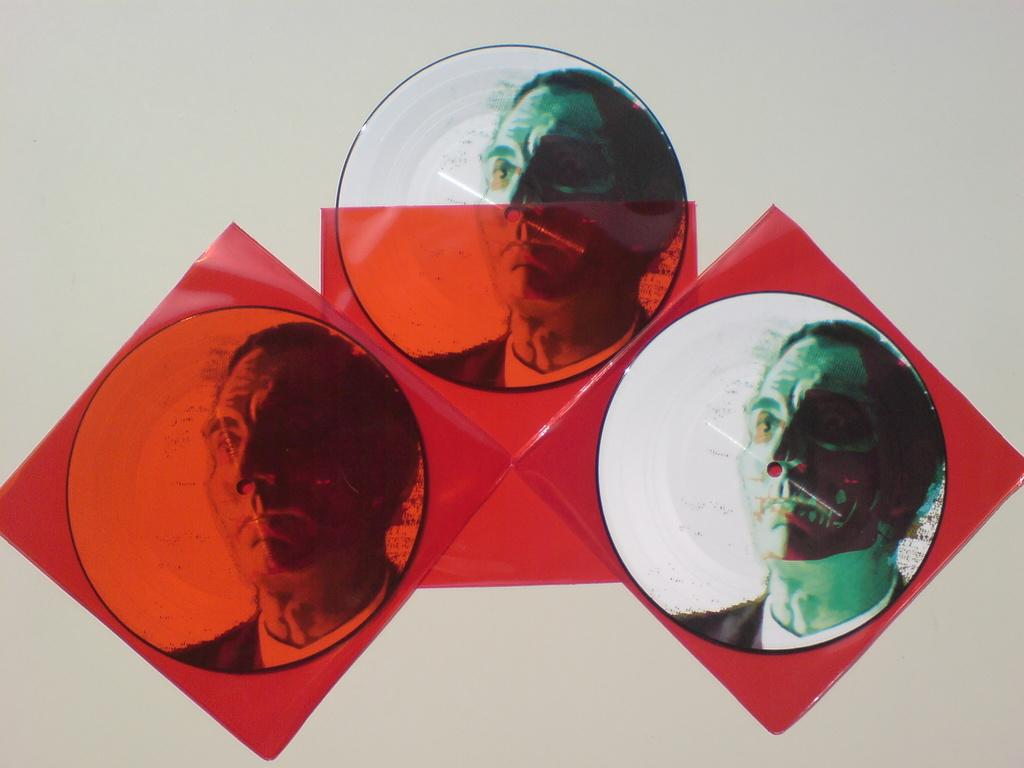What is the color of the covers visible in the image? The covers in the image are red. What type of photos are on the wall in the image? The photos on the wall are circular shaped and feature a person. How many baby birds are sitting on the station in the image? There are no baby birds or stations present in the image. 